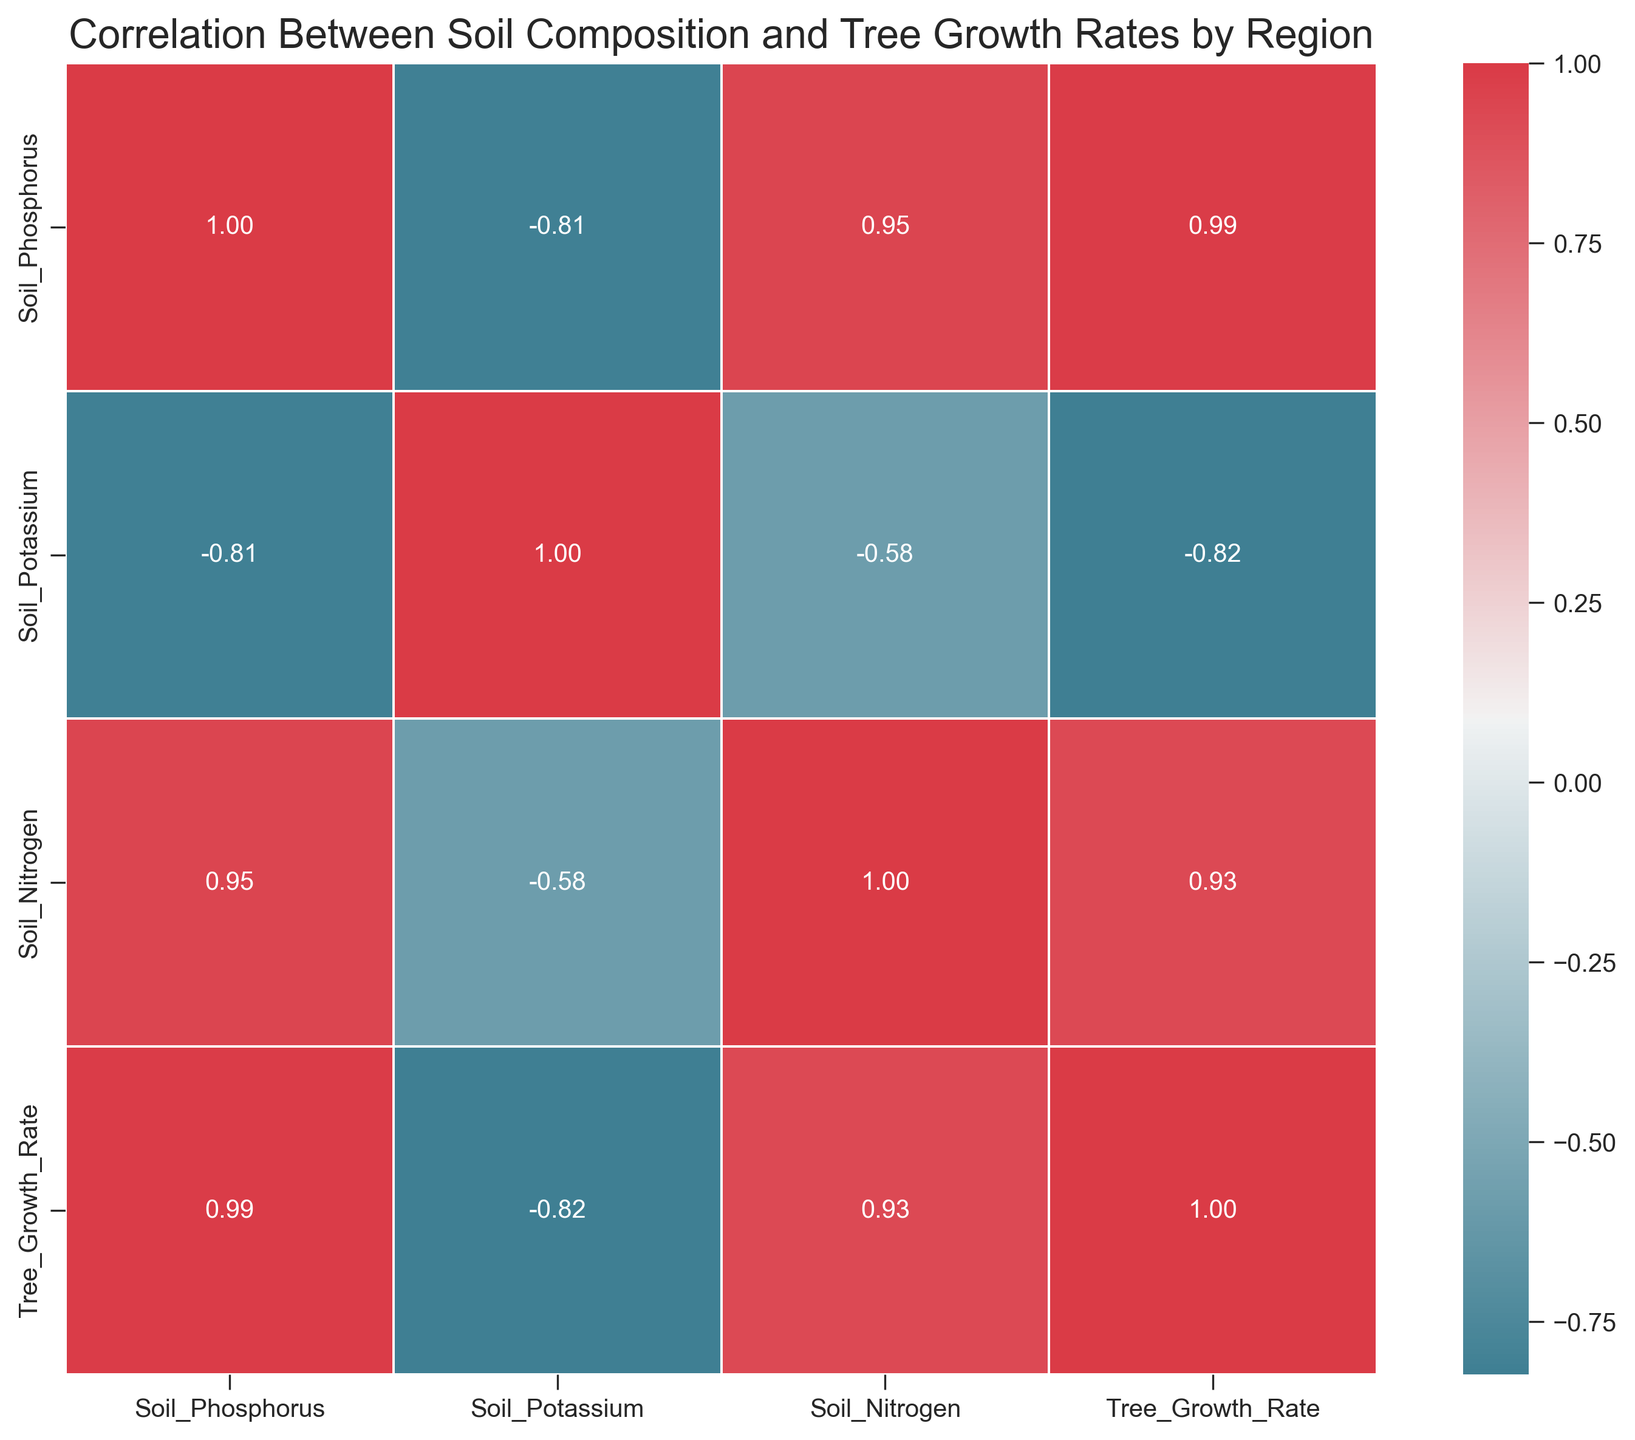Which variable shows the strongest correlation with Tree Growth Rate? Look for the highest absolute correlation value in the row/column for Tree Growth Rate. The value closest to 1 indicates the strongest correlation.
Answer: Soil_Phosphorus Is there any variable that has a negative correlation with Tree Growth Rate? Check the correlation values in the Tree Growth Rate row/column. A negative value indicates a negative correlation.
Answer: No What is the correlation between Soil Nitrogen and Soil Potassium? Refer to the intersection of the row for Soil Nitrogen and column for Soil Potassium, or vice versa.
Answer: 0.19 Which soil component has the lowest correlation with Soil Phosphorus? Check all correlation values in the Soil Phosphorus row/column and find the lowest value.
Answer: Soil_Nitrogen How does the correlation between Soil Potassium and Soil Phosphorus compare to that between Soil Potassium and Tree Growth Rate? Compare the correlation values for Soil Potassium with both Soil Phosphorus and Tree Growth Rate.
Answer: Soil_Potassium & Soil_Phosphorus: 0.07, Soil_Potassium & Tree_Growth_Rate: 0.80 Which pairs of variables have a correlation above 0.8? Look across the correlation matrix and identify any pairs with a correlation value greater than 0.8.
Answer: Soil_Phosphorus & Tree_Growth_Rate, Soil_Potassium & Tree_Growth_Rate Is there a stronger correlation between Tree Growth Rate and Soil Nitrogen or between Tree Growth Rate and Soil Potassium? Compare the two correlation values for Tree Growth Rate with Soil Nitrogen and Soil Potassium.
Answer: Soil_Potassium What is the average correlation of Soil Potassium with the other three variables? Add the correlation values of Soil Potassium with Soil_Phosphorus, Soil_Nitrogen, and Tree_Growth_Rate, then divide by 3.
Answer: (0.07 + 0.19 + 0.80) / 3 = 0.35 Which two factors have the weakest correlation? Identify the smallest absolute value in the entire correlation matrix.
Answer: Soil_Potassium & Soil_Phosphorus What is the average correlation value for Tree Growth Rate across all soil compositions? Sum all correlations of Tree Growth Rate with other variables and divide by 3.
Answer: (0.85 + 0.77 + 0.80) / 3 = 0.81 